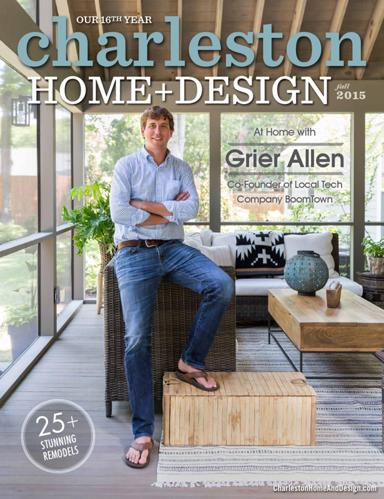What kind of remodeling projects are highlighted in the magazine? The magazine showcases 25 stunning remodels, ranging from comprehensive kitchen makeovers to luxurious bathroom overhauls, each demonstrating unique design challenges and innovative solutions. 